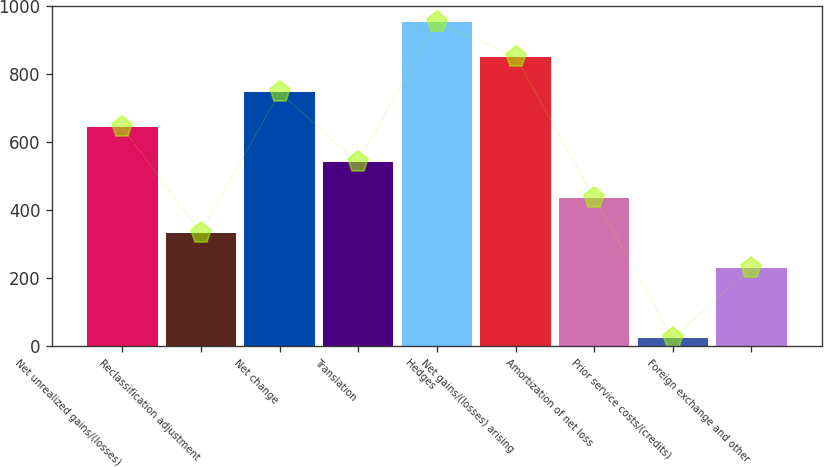Convert chart to OTSL. <chart><loc_0><loc_0><loc_500><loc_500><bar_chart><fcel>Net unrealized gains/(losses)<fcel>Reclassification adjustment<fcel>Net change<fcel>Translation<fcel>Hedges<fcel>Net gains/(losses) arising<fcel>Amortization of net loss<fcel>Prior service costs/(credits)<fcel>Foreign exchange and other<nl><fcel>642.8<fcel>332.9<fcel>746.1<fcel>539.5<fcel>952.7<fcel>849.4<fcel>436.2<fcel>23<fcel>229.6<nl></chart> 